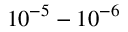Convert formula to latex. <formula><loc_0><loc_0><loc_500><loc_500>1 0 ^ { - 5 } - 1 0 ^ { - 6 }</formula> 